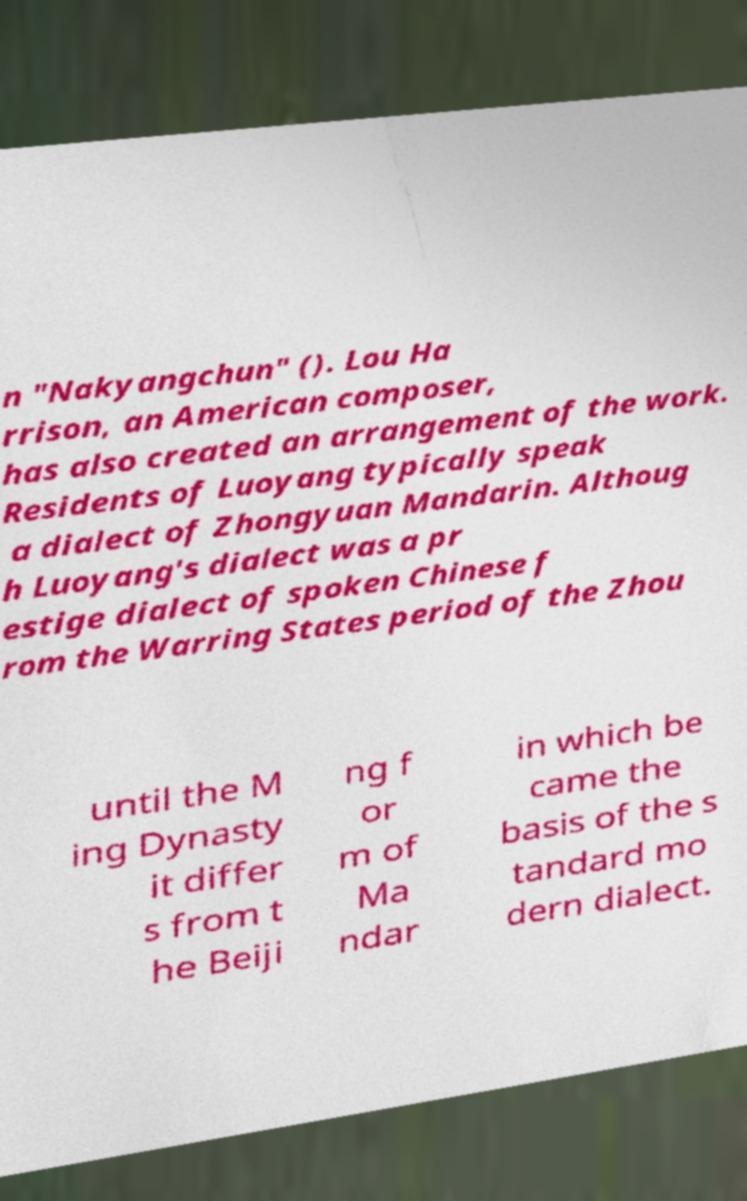For documentation purposes, I need the text within this image transcribed. Could you provide that? n "Nakyangchun" (). Lou Ha rrison, an American composer, has also created an arrangement of the work. Residents of Luoyang typically speak a dialect of Zhongyuan Mandarin. Althoug h Luoyang's dialect was a pr estige dialect of spoken Chinese f rom the Warring States period of the Zhou until the M ing Dynasty it differ s from t he Beiji ng f or m of Ma ndar in which be came the basis of the s tandard mo dern dialect. 